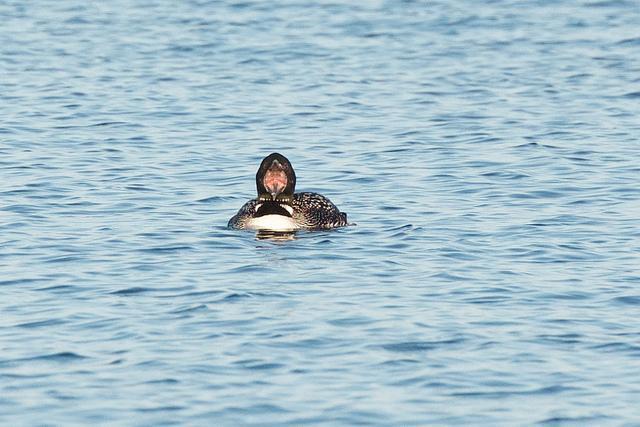How many ducks are in the photo?
Give a very brief answer. 1. 